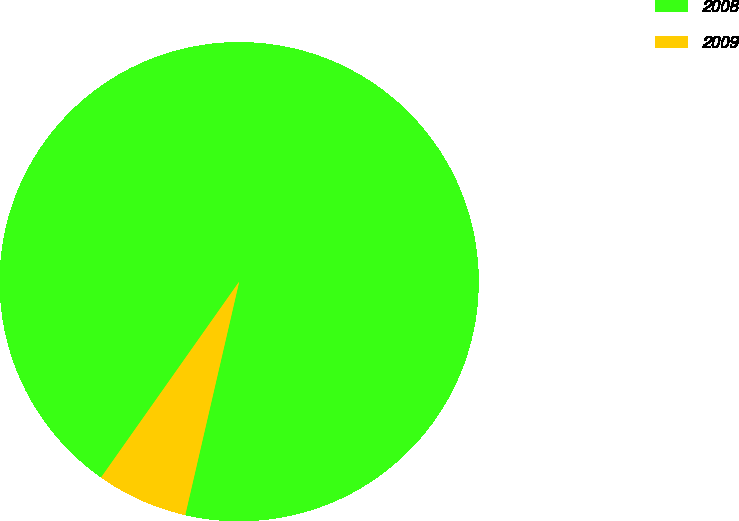Convert chart. <chart><loc_0><loc_0><loc_500><loc_500><pie_chart><fcel>2008<fcel>2009<nl><fcel>93.84%<fcel>6.16%<nl></chart> 